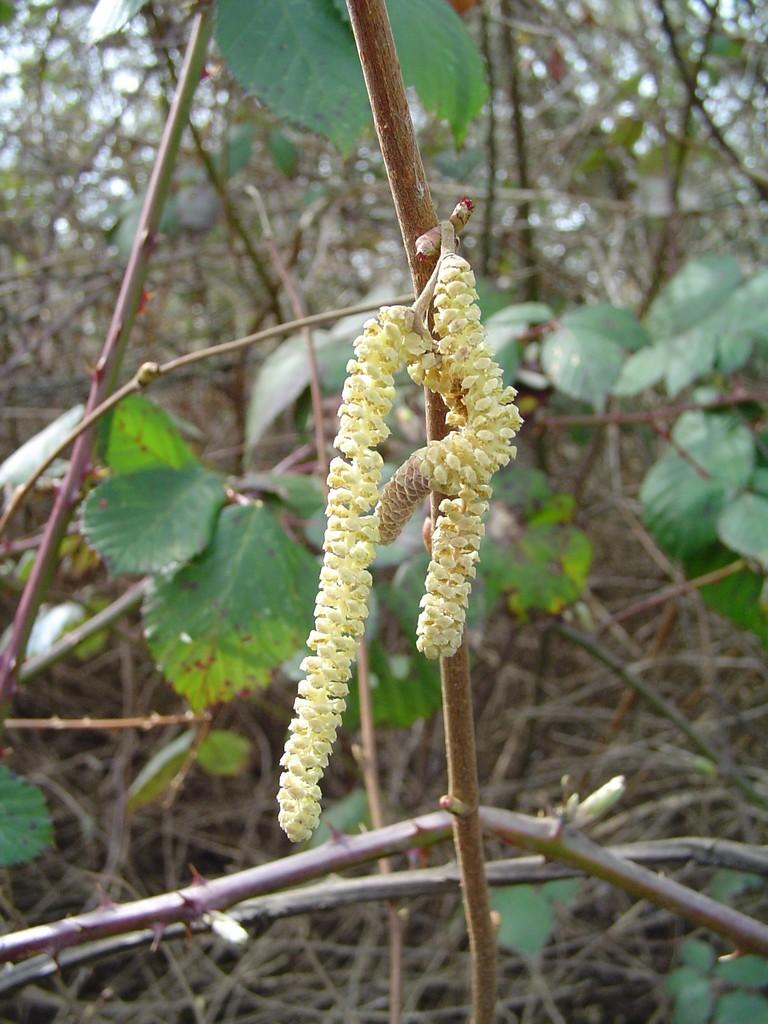What is the main subject in the center of the image? There is a stem with flowers in the center of the image. What can be seen in the background of the image? There are plants and leaves in the background of the image. What type of chalk is being used to draw on the plants in the image? There is no chalk or drawing activity present in the image; it features a stem with flowers and plants in the background. 